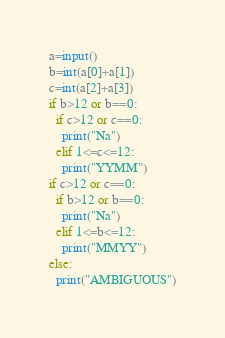<code> <loc_0><loc_0><loc_500><loc_500><_Python_>a=input()
b=int(a[0]+a[1])
c=int(a[2]+a[3])
if b>12 or b==0:
  if c>12 or c==0:
    print("Na")
  elif 1<=c<=12:
    print("YYMM")
if c>12 or c==0:
  if b>12 or b==0:
    print("Na")
  elif 1<=b<=12:
    print("MMYY")
else:
  print("AMBIGUOUS")</code> 